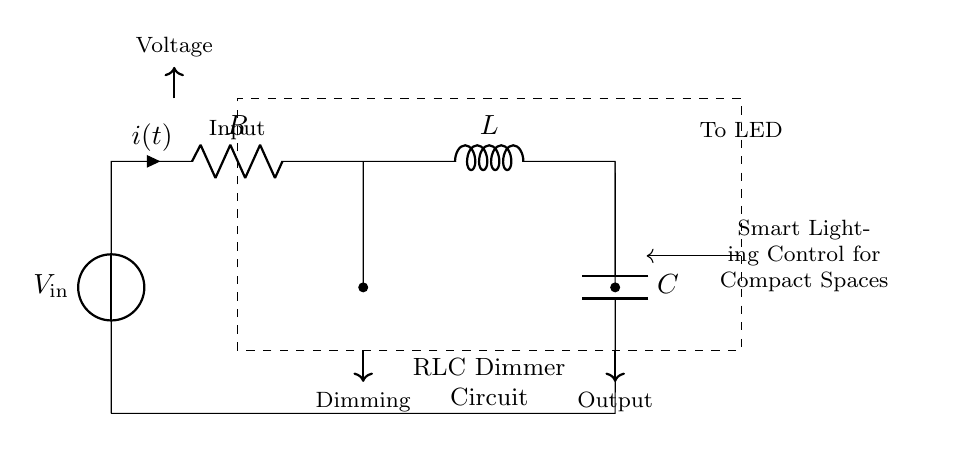What is the type of this circuit? The circuit is identified as a 'RLC Dimmer Circuit', indicated by the label and its use of resistors, inductors, and capacitors.
Answer: RLC Dimmer Circuit What components are involved in this circuit? The diagram shows three main components: a resistor, an inductor, and a capacitor, as labeled in the circuit.
Answer: Resistor, Inductor, Capacitor What is the purpose of this circuit? The purpose is to control smart lighting, as specified in the caption about 'Smart Lighting Control for Compact Spaces'.
Answer: Smart Lighting Control Where does the input voltage enter the circuit? The input voltage enters the circuit at the voltage source, marked as V_in at the top left corner of the diagram.
Answer: Voltage Source What does the current 'i(t)' represent? The current 'i(t)' represents the instantaneous current flowing through the resistor over time, as indicated by the label next to the resistor.
Answer: Instantaneous Current How does this circuit contribute to dimming the lights? The RLC circuit adjusts the phase and magnitude of the current flowing to the LED, allowing for light dimming; this is a function of the combined impedance of R, L, and C.
Answer: Adjusting current How are the outputs connected in this circuit? The outputs from the circuit lead directly to the LED, as shown by the arrow pointing from the circuit to 'To LED' on the right side of the diagram.
Answer: To LED 